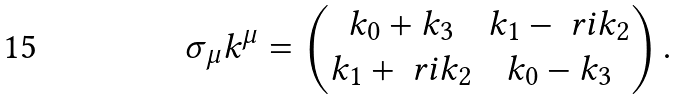Convert formula to latex. <formula><loc_0><loc_0><loc_500><loc_500>\sigma _ { \mu } k ^ { \mu } = \begin{pmatrix} k _ { 0 } + k _ { 3 } & k _ { 1 } - \ r i k _ { 2 } \\ k _ { 1 } + \ r i k _ { 2 } & k _ { 0 } - k _ { 3 } \end{pmatrix} .</formula> 